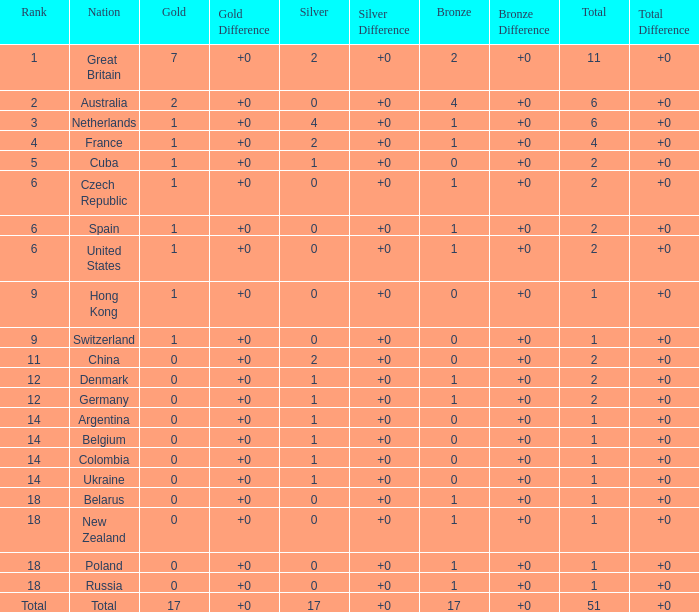Tell me the lowest gold for rank of 6 and total less than 2 None. 